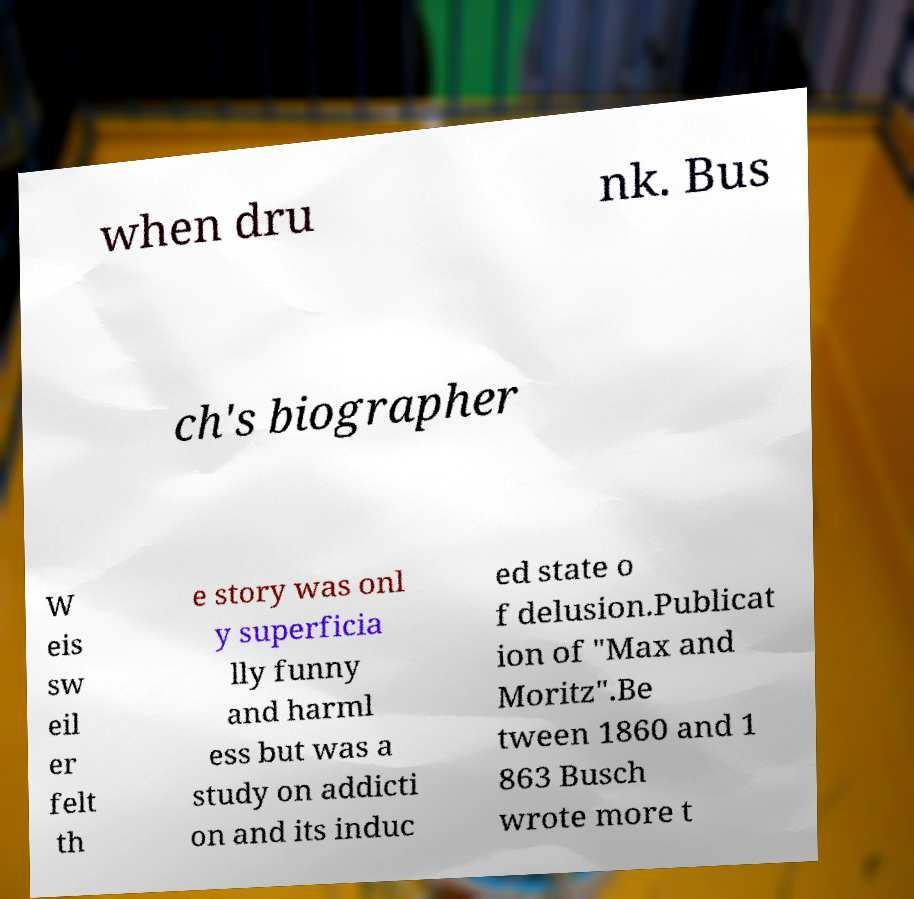There's text embedded in this image that I need extracted. Can you transcribe it verbatim? when dru nk. Bus ch's biographer W eis sw eil er felt th e story was onl y superficia lly funny and harml ess but was a study on addicti on and its induc ed state o f delusion.Publicat ion of "Max and Moritz".Be tween 1860 and 1 863 Busch wrote more t 